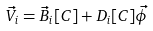<formula> <loc_0><loc_0><loc_500><loc_500>\vec { V } _ { i } = \vec { B } _ { i } [ C ] + D _ { i } [ C ] \vec { \phi }</formula> 